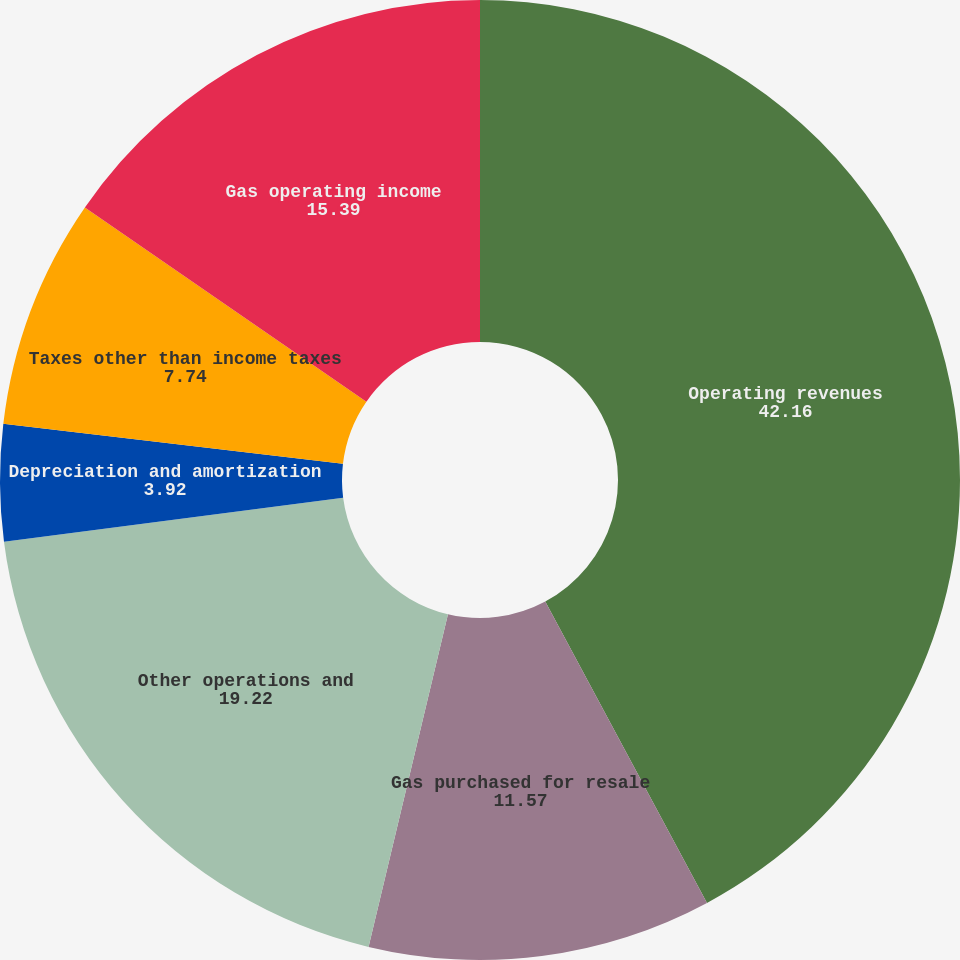<chart> <loc_0><loc_0><loc_500><loc_500><pie_chart><fcel>Operating revenues<fcel>Gas purchased for resale<fcel>Other operations and<fcel>Depreciation and amortization<fcel>Taxes other than income taxes<fcel>Gas operating income<nl><fcel>42.16%<fcel>11.57%<fcel>19.22%<fcel>3.92%<fcel>7.74%<fcel>15.39%<nl></chart> 